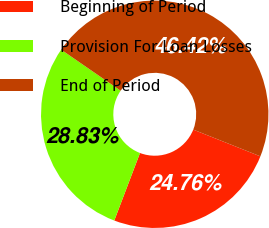<chart> <loc_0><loc_0><loc_500><loc_500><pie_chart><fcel>Beginning of Period<fcel>Provision For Loan Losses<fcel>End of Period<nl><fcel>24.76%<fcel>28.83%<fcel>46.42%<nl></chart> 